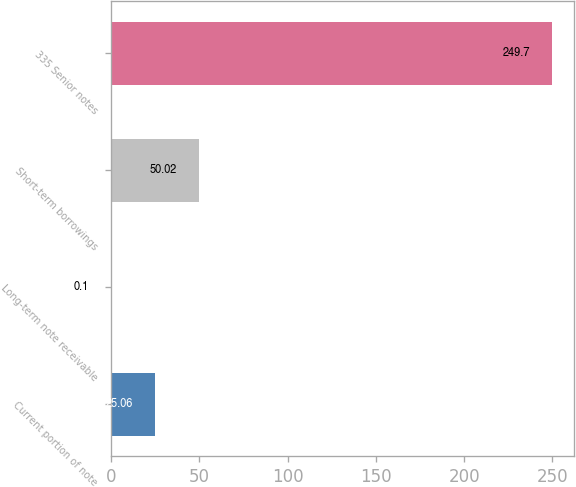<chart> <loc_0><loc_0><loc_500><loc_500><bar_chart><fcel>Current portion of note<fcel>Long-term note receivable<fcel>Short-term borrowings<fcel>335 Senior notes<nl><fcel>25.06<fcel>0.1<fcel>50.02<fcel>249.7<nl></chart> 